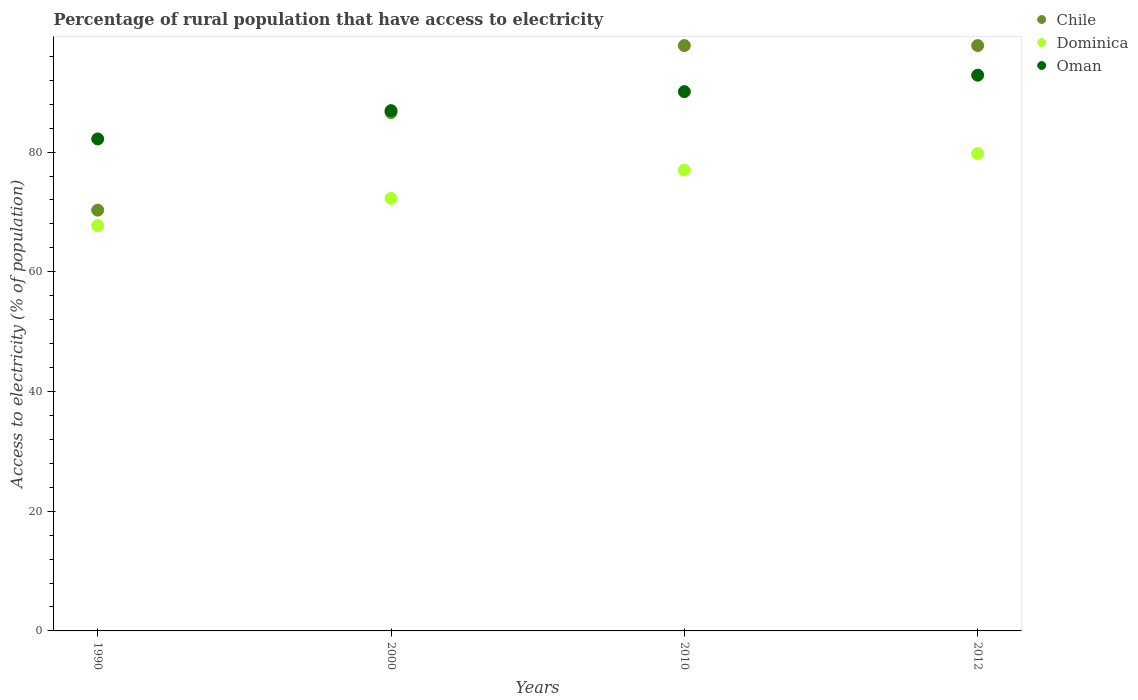What is the percentage of rural population that have access to electricity in Chile in 2000?
Keep it short and to the point. 86.6. Across all years, what is the maximum percentage of rural population that have access to electricity in Chile?
Ensure brevity in your answer.  97.8. Across all years, what is the minimum percentage of rural population that have access to electricity in Dominica?
Offer a very short reply. 67.71. In which year was the percentage of rural population that have access to electricity in Dominica maximum?
Your answer should be compact. 2012. What is the total percentage of rural population that have access to electricity in Oman in the graph?
Your answer should be very brief. 352.08. What is the difference between the percentage of rural population that have access to electricity in Oman in 1990 and that in 2012?
Offer a terse response. -10.65. What is the difference between the percentage of rural population that have access to electricity in Chile in 2000 and the percentage of rural population that have access to electricity in Dominica in 1990?
Ensure brevity in your answer.  18.89. What is the average percentage of rural population that have access to electricity in Dominica per year?
Your response must be concise. 74.18. In the year 2010, what is the difference between the percentage of rural population that have access to electricity in Dominica and percentage of rural population that have access to electricity in Oman?
Your answer should be very brief. -13.1. In how many years, is the percentage of rural population that have access to electricity in Oman greater than 36 %?
Your answer should be very brief. 4. What is the ratio of the percentage of rural population that have access to electricity in Chile in 2000 to that in 2010?
Keep it short and to the point. 0.89. What is the difference between the highest and the second highest percentage of rural population that have access to electricity in Oman?
Offer a terse response. 2.75. What is the difference between the highest and the lowest percentage of rural population that have access to electricity in Chile?
Provide a succinct answer. 27.5. Is it the case that in every year, the sum of the percentage of rural population that have access to electricity in Oman and percentage of rural population that have access to electricity in Dominica  is greater than the percentage of rural population that have access to electricity in Chile?
Make the answer very short. Yes. Is the percentage of rural population that have access to electricity in Dominica strictly less than the percentage of rural population that have access to electricity in Chile over the years?
Your response must be concise. Yes. How many dotlines are there?
Your response must be concise. 3. What is the difference between two consecutive major ticks on the Y-axis?
Offer a very short reply. 20. Does the graph contain any zero values?
Offer a very short reply. No. How many legend labels are there?
Your answer should be compact. 3. How are the legend labels stacked?
Offer a very short reply. Vertical. What is the title of the graph?
Ensure brevity in your answer.  Percentage of rural population that have access to electricity. What is the label or title of the Y-axis?
Make the answer very short. Access to electricity (% of population). What is the Access to electricity (% of population) of Chile in 1990?
Offer a terse response. 70.3. What is the Access to electricity (% of population) of Dominica in 1990?
Offer a terse response. 67.71. What is the Access to electricity (% of population) of Oman in 1990?
Your response must be concise. 82.2. What is the Access to electricity (% of population) in Chile in 2000?
Your answer should be very brief. 86.6. What is the Access to electricity (% of population) in Dominica in 2000?
Keep it short and to the point. 72.27. What is the Access to electricity (% of population) of Oman in 2000?
Keep it short and to the point. 86.93. What is the Access to electricity (% of population) in Chile in 2010?
Your answer should be very brief. 97.8. What is the Access to electricity (% of population) in Oman in 2010?
Keep it short and to the point. 90.1. What is the Access to electricity (% of population) of Chile in 2012?
Your response must be concise. 97.8. What is the Access to electricity (% of population) in Dominica in 2012?
Your answer should be very brief. 79.75. What is the Access to electricity (% of population) of Oman in 2012?
Give a very brief answer. 92.85. Across all years, what is the maximum Access to electricity (% of population) in Chile?
Offer a terse response. 97.8. Across all years, what is the maximum Access to electricity (% of population) of Dominica?
Provide a short and direct response. 79.75. Across all years, what is the maximum Access to electricity (% of population) of Oman?
Offer a terse response. 92.85. Across all years, what is the minimum Access to electricity (% of population) in Chile?
Offer a very short reply. 70.3. Across all years, what is the minimum Access to electricity (% of population) in Dominica?
Keep it short and to the point. 67.71. Across all years, what is the minimum Access to electricity (% of population) in Oman?
Provide a succinct answer. 82.2. What is the total Access to electricity (% of population) in Chile in the graph?
Your response must be concise. 352.5. What is the total Access to electricity (% of population) of Dominica in the graph?
Your answer should be compact. 296.73. What is the total Access to electricity (% of population) of Oman in the graph?
Your answer should be compact. 352.08. What is the difference between the Access to electricity (% of population) in Chile in 1990 and that in 2000?
Offer a very short reply. -16.3. What is the difference between the Access to electricity (% of population) of Dominica in 1990 and that in 2000?
Your answer should be compact. -4.55. What is the difference between the Access to electricity (% of population) of Oman in 1990 and that in 2000?
Ensure brevity in your answer.  -4.72. What is the difference between the Access to electricity (% of population) in Chile in 1990 and that in 2010?
Offer a very short reply. -27.5. What is the difference between the Access to electricity (% of population) in Dominica in 1990 and that in 2010?
Ensure brevity in your answer.  -9.29. What is the difference between the Access to electricity (% of population) of Oman in 1990 and that in 2010?
Your response must be concise. -7.9. What is the difference between the Access to electricity (% of population) of Chile in 1990 and that in 2012?
Your response must be concise. -27.5. What is the difference between the Access to electricity (% of population) of Dominica in 1990 and that in 2012?
Keep it short and to the point. -12.04. What is the difference between the Access to electricity (% of population) in Oman in 1990 and that in 2012?
Give a very brief answer. -10.65. What is the difference between the Access to electricity (% of population) of Chile in 2000 and that in 2010?
Keep it short and to the point. -11.2. What is the difference between the Access to electricity (% of population) of Dominica in 2000 and that in 2010?
Offer a terse response. -4.74. What is the difference between the Access to electricity (% of population) of Oman in 2000 and that in 2010?
Make the answer very short. -3.17. What is the difference between the Access to electricity (% of population) in Chile in 2000 and that in 2012?
Provide a short and direct response. -11.2. What is the difference between the Access to electricity (% of population) of Dominica in 2000 and that in 2012?
Offer a very short reply. -7.49. What is the difference between the Access to electricity (% of population) of Oman in 2000 and that in 2012?
Ensure brevity in your answer.  -5.93. What is the difference between the Access to electricity (% of population) in Dominica in 2010 and that in 2012?
Provide a short and direct response. -2.75. What is the difference between the Access to electricity (% of population) of Oman in 2010 and that in 2012?
Provide a short and direct response. -2.75. What is the difference between the Access to electricity (% of population) of Chile in 1990 and the Access to electricity (% of population) of Dominica in 2000?
Give a very brief answer. -1.97. What is the difference between the Access to electricity (% of population) of Chile in 1990 and the Access to electricity (% of population) of Oman in 2000?
Your answer should be very brief. -16.63. What is the difference between the Access to electricity (% of population) of Dominica in 1990 and the Access to electricity (% of population) of Oman in 2000?
Offer a terse response. -19.21. What is the difference between the Access to electricity (% of population) in Chile in 1990 and the Access to electricity (% of population) in Oman in 2010?
Make the answer very short. -19.8. What is the difference between the Access to electricity (% of population) in Dominica in 1990 and the Access to electricity (% of population) in Oman in 2010?
Your answer should be compact. -22.39. What is the difference between the Access to electricity (% of population) in Chile in 1990 and the Access to electricity (% of population) in Dominica in 2012?
Provide a succinct answer. -9.45. What is the difference between the Access to electricity (% of population) in Chile in 1990 and the Access to electricity (% of population) in Oman in 2012?
Your answer should be compact. -22.55. What is the difference between the Access to electricity (% of population) of Dominica in 1990 and the Access to electricity (% of population) of Oman in 2012?
Provide a succinct answer. -25.14. What is the difference between the Access to electricity (% of population) of Chile in 2000 and the Access to electricity (% of population) of Dominica in 2010?
Offer a very short reply. 9.6. What is the difference between the Access to electricity (% of population) of Dominica in 2000 and the Access to electricity (% of population) of Oman in 2010?
Ensure brevity in your answer.  -17.84. What is the difference between the Access to electricity (% of population) in Chile in 2000 and the Access to electricity (% of population) in Dominica in 2012?
Offer a very short reply. 6.85. What is the difference between the Access to electricity (% of population) of Chile in 2000 and the Access to electricity (% of population) of Oman in 2012?
Offer a very short reply. -6.25. What is the difference between the Access to electricity (% of population) of Dominica in 2000 and the Access to electricity (% of population) of Oman in 2012?
Give a very brief answer. -20.59. What is the difference between the Access to electricity (% of population) of Chile in 2010 and the Access to electricity (% of population) of Dominica in 2012?
Offer a terse response. 18.05. What is the difference between the Access to electricity (% of population) of Chile in 2010 and the Access to electricity (% of population) of Oman in 2012?
Your answer should be compact. 4.95. What is the difference between the Access to electricity (% of population) in Dominica in 2010 and the Access to electricity (% of population) in Oman in 2012?
Your answer should be compact. -15.85. What is the average Access to electricity (% of population) in Chile per year?
Make the answer very short. 88.12. What is the average Access to electricity (% of population) in Dominica per year?
Make the answer very short. 74.18. What is the average Access to electricity (% of population) in Oman per year?
Ensure brevity in your answer.  88.02. In the year 1990, what is the difference between the Access to electricity (% of population) of Chile and Access to electricity (% of population) of Dominica?
Your response must be concise. 2.59. In the year 1990, what is the difference between the Access to electricity (% of population) of Chile and Access to electricity (% of population) of Oman?
Offer a terse response. -11.9. In the year 1990, what is the difference between the Access to electricity (% of population) of Dominica and Access to electricity (% of population) of Oman?
Ensure brevity in your answer.  -14.49. In the year 2000, what is the difference between the Access to electricity (% of population) of Chile and Access to electricity (% of population) of Dominica?
Your response must be concise. 14.34. In the year 2000, what is the difference between the Access to electricity (% of population) in Chile and Access to electricity (% of population) in Oman?
Offer a terse response. -0.33. In the year 2000, what is the difference between the Access to electricity (% of population) of Dominica and Access to electricity (% of population) of Oman?
Provide a short and direct response. -14.66. In the year 2010, what is the difference between the Access to electricity (% of population) of Chile and Access to electricity (% of population) of Dominica?
Your response must be concise. 20.8. In the year 2010, what is the difference between the Access to electricity (% of population) in Chile and Access to electricity (% of population) in Oman?
Provide a succinct answer. 7.7. In the year 2012, what is the difference between the Access to electricity (% of population) in Chile and Access to electricity (% of population) in Dominica?
Ensure brevity in your answer.  18.05. In the year 2012, what is the difference between the Access to electricity (% of population) of Chile and Access to electricity (% of population) of Oman?
Offer a very short reply. 4.95. What is the ratio of the Access to electricity (% of population) of Chile in 1990 to that in 2000?
Offer a terse response. 0.81. What is the ratio of the Access to electricity (% of population) of Dominica in 1990 to that in 2000?
Provide a succinct answer. 0.94. What is the ratio of the Access to electricity (% of population) of Oman in 1990 to that in 2000?
Make the answer very short. 0.95. What is the ratio of the Access to electricity (% of population) in Chile in 1990 to that in 2010?
Give a very brief answer. 0.72. What is the ratio of the Access to electricity (% of population) in Dominica in 1990 to that in 2010?
Offer a very short reply. 0.88. What is the ratio of the Access to electricity (% of population) of Oman in 1990 to that in 2010?
Your answer should be very brief. 0.91. What is the ratio of the Access to electricity (% of population) of Chile in 1990 to that in 2012?
Provide a short and direct response. 0.72. What is the ratio of the Access to electricity (% of population) in Dominica in 1990 to that in 2012?
Offer a terse response. 0.85. What is the ratio of the Access to electricity (% of population) in Oman in 1990 to that in 2012?
Your response must be concise. 0.89. What is the ratio of the Access to electricity (% of population) in Chile in 2000 to that in 2010?
Your response must be concise. 0.89. What is the ratio of the Access to electricity (% of population) of Dominica in 2000 to that in 2010?
Offer a very short reply. 0.94. What is the ratio of the Access to electricity (% of population) of Oman in 2000 to that in 2010?
Your response must be concise. 0.96. What is the ratio of the Access to electricity (% of population) in Chile in 2000 to that in 2012?
Offer a terse response. 0.89. What is the ratio of the Access to electricity (% of population) in Dominica in 2000 to that in 2012?
Your response must be concise. 0.91. What is the ratio of the Access to electricity (% of population) of Oman in 2000 to that in 2012?
Offer a very short reply. 0.94. What is the ratio of the Access to electricity (% of population) in Chile in 2010 to that in 2012?
Keep it short and to the point. 1. What is the ratio of the Access to electricity (% of population) of Dominica in 2010 to that in 2012?
Offer a very short reply. 0.97. What is the ratio of the Access to electricity (% of population) of Oman in 2010 to that in 2012?
Offer a terse response. 0.97. What is the difference between the highest and the second highest Access to electricity (% of population) of Chile?
Give a very brief answer. 0. What is the difference between the highest and the second highest Access to electricity (% of population) of Dominica?
Provide a short and direct response. 2.75. What is the difference between the highest and the second highest Access to electricity (% of population) in Oman?
Your response must be concise. 2.75. What is the difference between the highest and the lowest Access to electricity (% of population) in Dominica?
Your answer should be very brief. 12.04. What is the difference between the highest and the lowest Access to electricity (% of population) of Oman?
Your response must be concise. 10.65. 